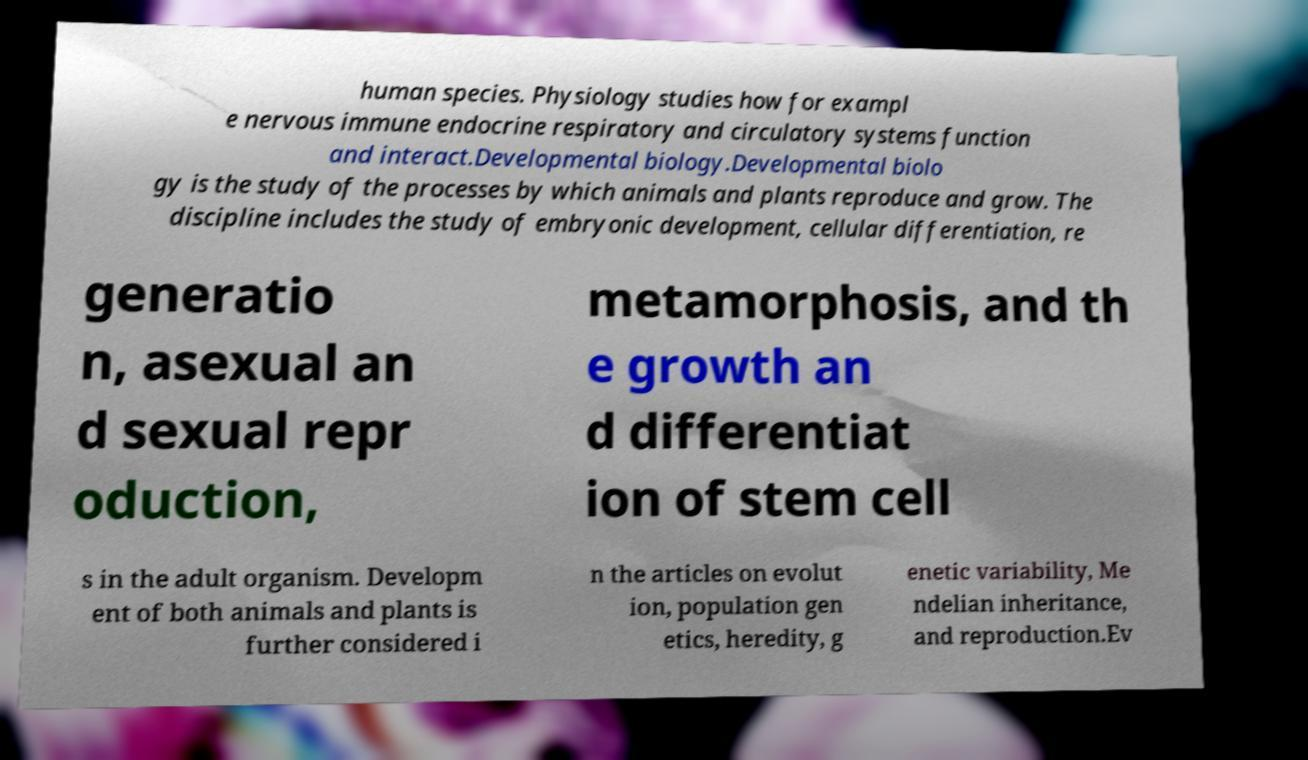Can you accurately transcribe the text from the provided image for me? human species. Physiology studies how for exampl e nervous immune endocrine respiratory and circulatory systems function and interact.Developmental biology.Developmental biolo gy is the study of the processes by which animals and plants reproduce and grow. The discipline includes the study of embryonic development, cellular differentiation, re generatio n, asexual an d sexual repr oduction, metamorphosis, and th e growth an d differentiat ion of stem cell s in the adult organism. Developm ent of both animals and plants is further considered i n the articles on evolut ion, population gen etics, heredity, g enetic variability, Me ndelian inheritance, and reproduction.Ev 